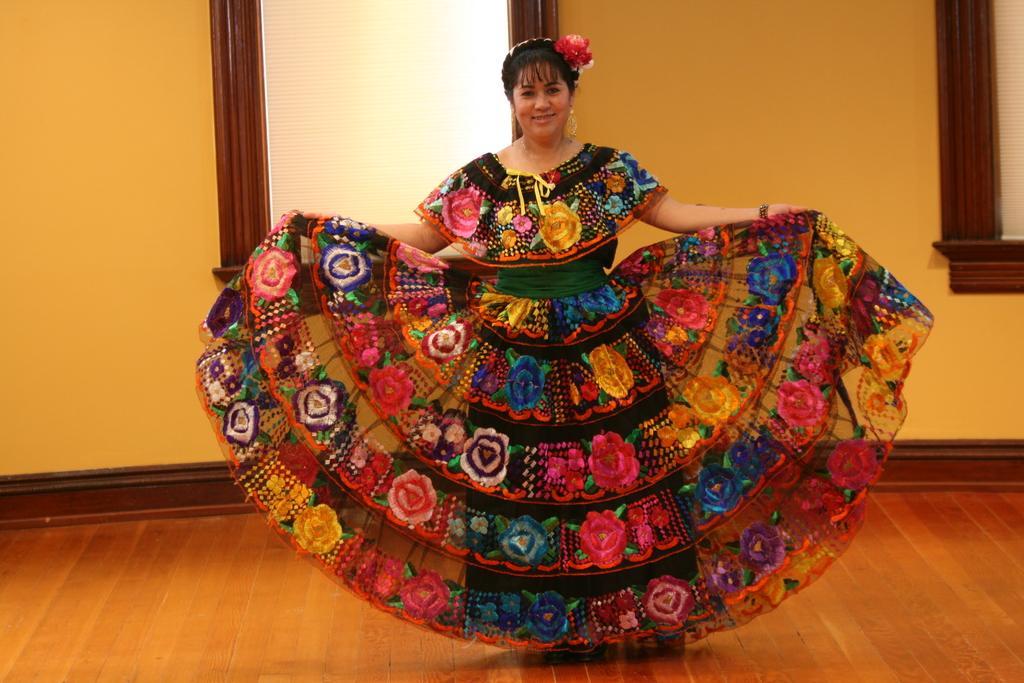In one or two sentences, can you explain what this image depicts? This image consists of a woman. She is wearing a frock. She is wearing earrings and hair band. There are windows behind her. 